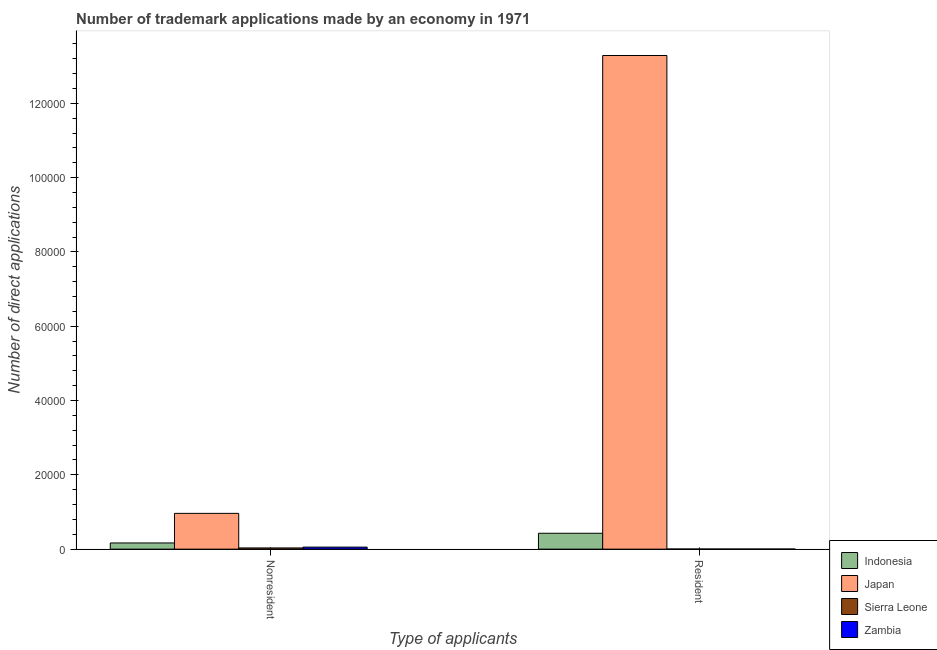Are the number of bars per tick equal to the number of legend labels?
Your answer should be very brief. Yes. How many bars are there on the 1st tick from the left?
Make the answer very short. 4. What is the label of the 1st group of bars from the left?
Your response must be concise. Nonresident. What is the number of trademark applications made by non residents in Sierra Leone?
Your answer should be compact. 328. Across all countries, what is the maximum number of trademark applications made by non residents?
Your answer should be compact. 9632. Across all countries, what is the minimum number of trademark applications made by non residents?
Provide a short and direct response. 328. In which country was the number of trademark applications made by residents maximum?
Your answer should be compact. Japan. In which country was the number of trademark applications made by non residents minimum?
Offer a very short reply. Sierra Leone. What is the total number of trademark applications made by residents in the graph?
Ensure brevity in your answer.  1.37e+05. What is the difference between the number of trademark applications made by non residents in Sierra Leone and that in Zambia?
Your answer should be very brief. -218. What is the difference between the number of trademark applications made by residents in Japan and the number of trademark applications made by non residents in Zambia?
Provide a succinct answer. 1.32e+05. What is the average number of trademark applications made by residents per country?
Your answer should be very brief. 3.43e+04. What is the difference between the number of trademark applications made by non residents and number of trademark applications made by residents in Indonesia?
Ensure brevity in your answer.  -2608. In how many countries, is the number of trademark applications made by residents greater than 8000 ?
Offer a very short reply. 1. What is the ratio of the number of trademark applications made by residents in Japan to that in Sierra Leone?
Offer a terse response. 3908.41. Is the number of trademark applications made by non residents in Indonesia less than that in Japan?
Offer a very short reply. Yes. In how many countries, is the number of trademark applications made by non residents greater than the average number of trademark applications made by non residents taken over all countries?
Your answer should be compact. 1. What does the 1st bar from the right in Resident represents?
Make the answer very short. Zambia. How many bars are there?
Offer a terse response. 8. Are all the bars in the graph horizontal?
Provide a succinct answer. No. How many legend labels are there?
Your response must be concise. 4. What is the title of the graph?
Your response must be concise. Number of trademark applications made by an economy in 1971. What is the label or title of the X-axis?
Provide a succinct answer. Type of applicants. What is the label or title of the Y-axis?
Ensure brevity in your answer.  Number of direct applications. What is the Number of direct applications in Indonesia in Nonresident?
Make the answer very short. 1668. What is the Number of direct applications in Japan in Nonresident?
Provide a succinct answer. 9632. What is the Number of direct applications of Sierra Leone in Nonresident?
Offer a terse response. 328. What is the Number of direct applications of Zambia in Nonresident?
Your response must be concise. 546. What is the Number of direct applications in Indonesia in Resident?
Offer a terse response. 4276. What is the Number of direct applications in Japan in Resident?
Keep it short and to the point. 1.33e+05. Across all Type of applicants, what is the maximum Number of direct applications in Indonesia?
Your answer should be compact. 4276. Across all Type of applicants, what is the maximum Number of direct applications in Japan?
Your response must be concise. 1.33e+05. Across all Type of applicants, what is the maximum Number of direct applications of Sierra Leone?
Ensure brevity in your answer.  328. Across all Type of applicants, what is the maximum Number of direct applications of Zambia?
Make the answer very short. 546. Across all Type of applicants, what is the minimum Number of direct applications of Indonesia?
Keep it short and to the point. 1668. Across all Type of applicants, what is the minimum Number of direct applications in Japan?
Your response must be concise. 9632. Across all Type of applicants, what is the minimum Number of direct applications of Sierra Leone?
Keep it short and to the point. 34. What is the total Number of direct applications of Indonesia in the graph?
Provide a short and direct response. 5944. What is the total Number of direct applications of Japan in the graph?
Make the answer very short. 1.43e+05. What is the total Number of direct applications in Sierra Leone in the graph?
Offer a very short reply. 362. What is the total Number of direct applications of Zambia in the graph?
Your response must be concise. 574. What is the difference between the Number of direct applications in Indonesia in Nonresident and that in Resident?
Make the answer very short. -2608. What is the difference between the Number of direct applications of Japan in Nonresident and that in Resident?
Ensure brevity in your answer.  -1.23e+05. What is the difference between the Number of direct applications of Sierra Leone in Nonresident and that in Resident?
Offer a very short reply. 294. What is the difference between the Number of direct applications of Zambia in Nonresident and that in Resident?
Your answer should be compact. 518. What is the difference between the Number of direct applications of Indonesia in Nonresident and the Number of direct applications of Japan in Resident?
Make the answer very short. -1.31e+05. What is the difference between the Number of direct applications of Indonesia in Nonresident and the Number of direct applications of Sierra Leone in Resident?
Your answer should be compact. 1634. What is the difference between the Number of direct applications in Indonesia in Nonresident and the Number of direct applications in Zambia in Resident?
Your response must be concise. 1640. What is the difference between the Number of direct applications in Japan in Nonresident and the Number of direct applications in Sierra Leone in Resident?
Your answer should be compact. 9598. What is the difference between the Number of direct applications of Japan in Nonresident and the Number of direct applications of Zambia in Resident?
Ensure brevity in your answer.  9604. What is the difference between the Number of direct applications of Sierra Leone in Nonresident and the Number of direct applications of Zambia in Resident?
Provide a succinct answer. 300. What is the average Number of direct applications in Indonesia per Type of applicants?
Keep it short and to the point. 2972. What is the average Number of direct applications of Japan per Type of applicants?
Your answer should be compact. 7.13e+04. What is the average Number of direct applications in Sierra Leone per Type of applicants?
Keep it short and to the point. 181. What is the average Number of direct applications in Zambia per Type of applicants?
Provide a succinct answer. 287. What is the difference between the Number of direct applications of Indonesia and Number of direct applications of Japan in Nonresident?
Your response must be concise. -7964. What is the difference between the Number of direct applications of Indonesia and Number of direct applications of Sierra Leone in Nonresident?
Offer a very short reply. 1340. What is the difference between the Number of direct applications of Indonesia and Number of direct applications of Zambia in Nonresident?
Your response must be concise. 1122. What is the difference between the Number of direct applications of Japan and Number of direct applications of Sierra Leone in Nonresident?
Give a very brief answer. 9304. What is the difference between the Number of direct applications of Japan and Number of direct applications of Zambia in Nonresident?
Provide a short and direct response. 9086. What is the difference between the Number of direct applications of Sierra Leone and Number of direct applications of Zambia in Nonresident?
Provide a succinct answer. -218. What is the difference between the Number of direct applications in Indonesia and Number of direct applications in Japan in Resident?
Give a very brief answer. -1.29e+05. What is the difference between the Number of direct applications of Indonesia and Number of direct applications of Sierra Leone in Resident?
Ensure brevity in your answer.  4242. What is the difference between the Number of direct applications of Indonesia and Number of direct applications of Zambia in Resident?
Provide a succinct answer. 4248. What is the difference between the Number of direct applications of Japan and Number of direct applications of Sierra Leone in Resident?
Provide a short and direct response. 1.33e+05. What is the difference between the Number of direct applications of Japan and Number of direct applications of Zambia in Resident?
Your response must be concise. 1.33e+05. What is the difference between the Number of direct applications in Sierra Leone and Number of direct applications in Zambia in Resident?
Offer a very short reply. 6. What is the ratio of the Number of direct applications in Indonesia in Nonresident to that in Resident?
Keep it short and to the point. 0.39. What is the ratio of the Number of direct applications of Japan in Nonresident to that in Resident?
Provide a short and direct response. 0.07. What is the ratio of the Number of direct applications in Sierra Leone in Nonresident to that in Resident?
Provide a succinct answer. 9.65. What is the ratio of the Number of direct applications of Zambia in Nonresident to that in Resident?
Your answer should be very brief. 19.5. What is the difference between the highest and the second highest Number of direct applications of Indonesia?
Offer a very short reply. 2608. What is the difference between the highest and the second highest Number of direct applications of Japan?
Your answer should be very brief. 1.23e+05. What is the difference between the highest and the second highest Number of direct applications of Sierra Leone?
Ensure brevity in your answer.  294. What is the difference between the highest and the second highest Number of direct applications in Zambia?
Your response must be concise. 518. What is the difference between the highest and the lowest Number of direct applications in Indonesia?
Ensure brevity in your answer.  2608. What is the difference between the highest and the lowest Number of direct applications of Japan?
Your answer should be very brief. 1.23e+05. What is the difference between the highest and the lowest Number of direct applications in Sierra Leone?
Provide a short and direct response. 294. What is the difference between the highest and the lowest Number of direct applications of Zambia?
Offer a very short reply. 518. 